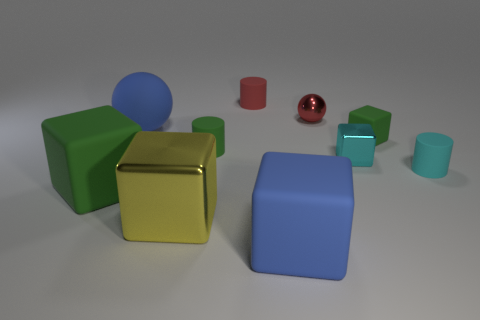What material is the tiny object that is behind the small green cube and in front of the red cylinder?
Ensure brevity in your answer.  Metal. Is the number of big green cubes behind the small metallic sphere less than the number of big blue matte things behind the small cyan cube?
Offer a very short reply. Yes. What is the size of the red cylinder that is made of the same material as the cyan cylinder?
Provide a short and direct response. Small. Are there any other things that have the same color as the small matte block?
Provide a succinct answer. Yes. Is the material of the large ball the same as the cylinder behind the tiny red metallic object?
Give a very brief answer. Yes. There is a small red object that is the same shape as the tiny cyan matte thing; what is its material?
Your answer should be compact. Rubber. Is the small green cylinder that is left of the tiny matte cube made of the same material as the cyan thing that is left of the cyan cylinder?
Offer a very short reply. No. There is a big matte block that is in front of the green thing to the left of the big rubber thing that is behind the small cyan block; what is its color?
Provide a succinct answer. Blue. How many other things are there of the same shape as the cyan metal thing?
Offer a very short reply. 4. How many objects are either green spheres or blue blocks that are in front of the cyan metallic object?
Keep it short and to the point. 1. 